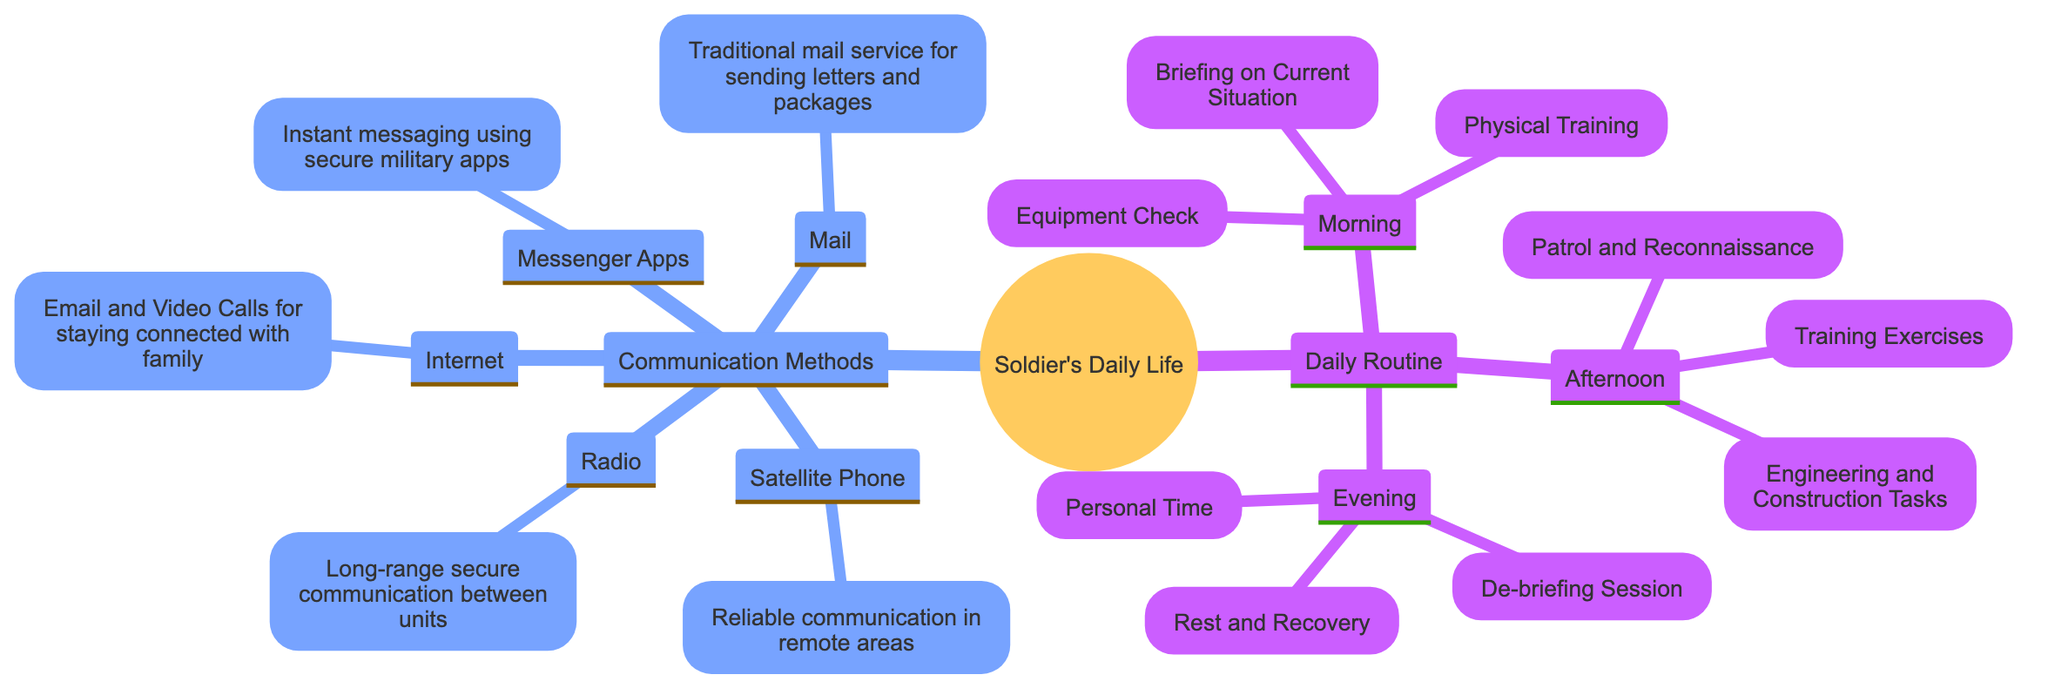What are the three parts of a soldier's daily routine? The diagram outlines three main parts of a soldier's daily routine: Morning, Afternoon, and Evening. Each part includes specific activities, making them identifiable.
Answer: Morning, Afternoon, Evening How many communication methods are listed in the diagram? The diagram specifies a total of five communication methods. These methods are clearly enumerated under the "Communication Methods" section.
Answer: Five What is the first activity in the morning routine? The morning routine starts with "Physical Training," which is the first listed activity in the diagram under the Morning section.
Answer: Physical Training Which communication method is used for long-range secure communication? The "Radio" is indicated in the diagram as the method for long-range secure communication between units, making it clear which method serves this purpose.
Answer: Radio How many activities are there in the Evening routine? The Evening section of the diagram lists three activities: "De-briefing Session," "Personal Time," and "Rest and Recovery." Counting these gives the number of activities in this part.
Answer: Three What is the purpose of the Satellite Phone in the diagram? The diagram outlines that the purpose of the Satellite Phone is for "Reliable communication in remote areas," which is stated directly under this communication method.
Answer: Reliable communication in remote areas If a soldier is off duty in the evening, what activity will they likely engage in? During the Evening routine, one identified activity is "Personal Time." Therefore, if a soldier is off duty, they would likely engage in this activity.
Answer: Personal Time What activities occur in the Afternoon routine? The Afternoon routine includes three activities: "Patrol and Reconnaissance," "Engineering and Construction Tasks," and "Training Exercises." Listing them identifies the full set.
Answer: Patrol and Reconnaissance, Engineering and Construction Tasks, Training Exercises Which communication method allows for instant messaging? The diagram specifies "Messenger Apps" as the method used for instant messaging, directly indicating its function among the communication methods.
Answer: Messenger Apps 